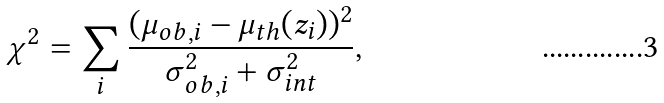Convert formula to latex. <formula><loc_0><loc_0><loc_500><loc_500>\chi ^ { 2 } = \sum _ { i } \frac { ( \mu _ { o b , i } - \mu _ { t h } ( z _ { i } ) ) ^ { 2 } } { \sigma _ { o b , i } ^ { 2 } + \sigma _ { i n t } ^ { 2 } } ,</formula> 